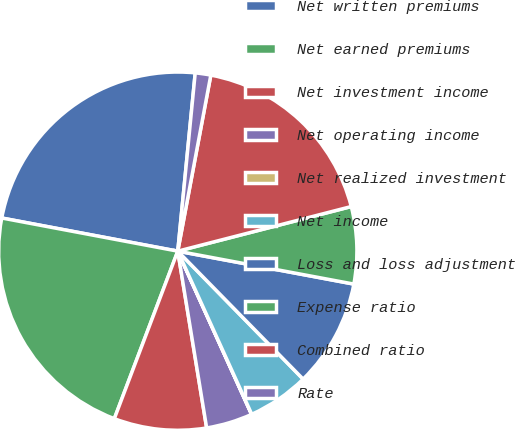Convert chart. <chart><loc_0><loc_0><loc_500><loc_500><pie_chart><fcel>Net written premiums<fcel>Net earned premiums<fcel>Net investment income<fcel>Net operating income<fcel>Net realized investment<fcel>Net income<fcel>Loss and loss adjustment<fcel>Expense ratio<fcel>Combined ratio<fcel>Rate<nl><fcel>23.59%<fcel>22.2%<fcel>8.34%<fcel>4.18%<fcel>0.02%<fcel>5.56%<fcel>9.72%<fcel>6.95%<fcel>18.04%<fcel>1.4%<nl></chart> 